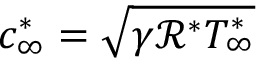Convert formula to latex. <formula><loc_0><loc_0><loc_500><loc_500>c _ { \infty } ^ { \ast } = \sqrt { \gamma \mathcal { R } ^ { \ast } T _ { \infty } ^ { \ast } }</formula> 